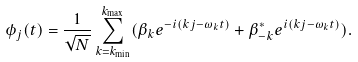<formula> <loc_0><loc_0><loc_500><loc_500>\phi _ { j } ( t ) = \frac { 1 } { \sqrt { N } } \sum _ { k = k _ { \min } } ^ { k _ { \max } } ( \beta _ { k } e ^ { - i ( k j - \omega _ { k } t ) } + \beta _ { - k } ^ { * } e ^ { i ( k j - \omega _ { k } t ) } ) .</formula> 